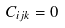Convert formula to latex. <formula><loc_0><loc_0><loc_500><loc_500>C _ { i j k } = 0</formula> 